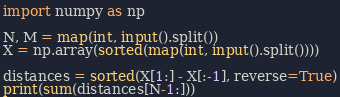Convert code to text. <code><loc_0><loc_0><loc_500><loc_500><_Python_>import numpy as np

N, M = map(int, input().split())
X = np.array(sorted(map(int, input().split())))

distances = sorted(X[1:] - X[:-1], reverse=True)
print(sum(distances[N-1:]))</code> 